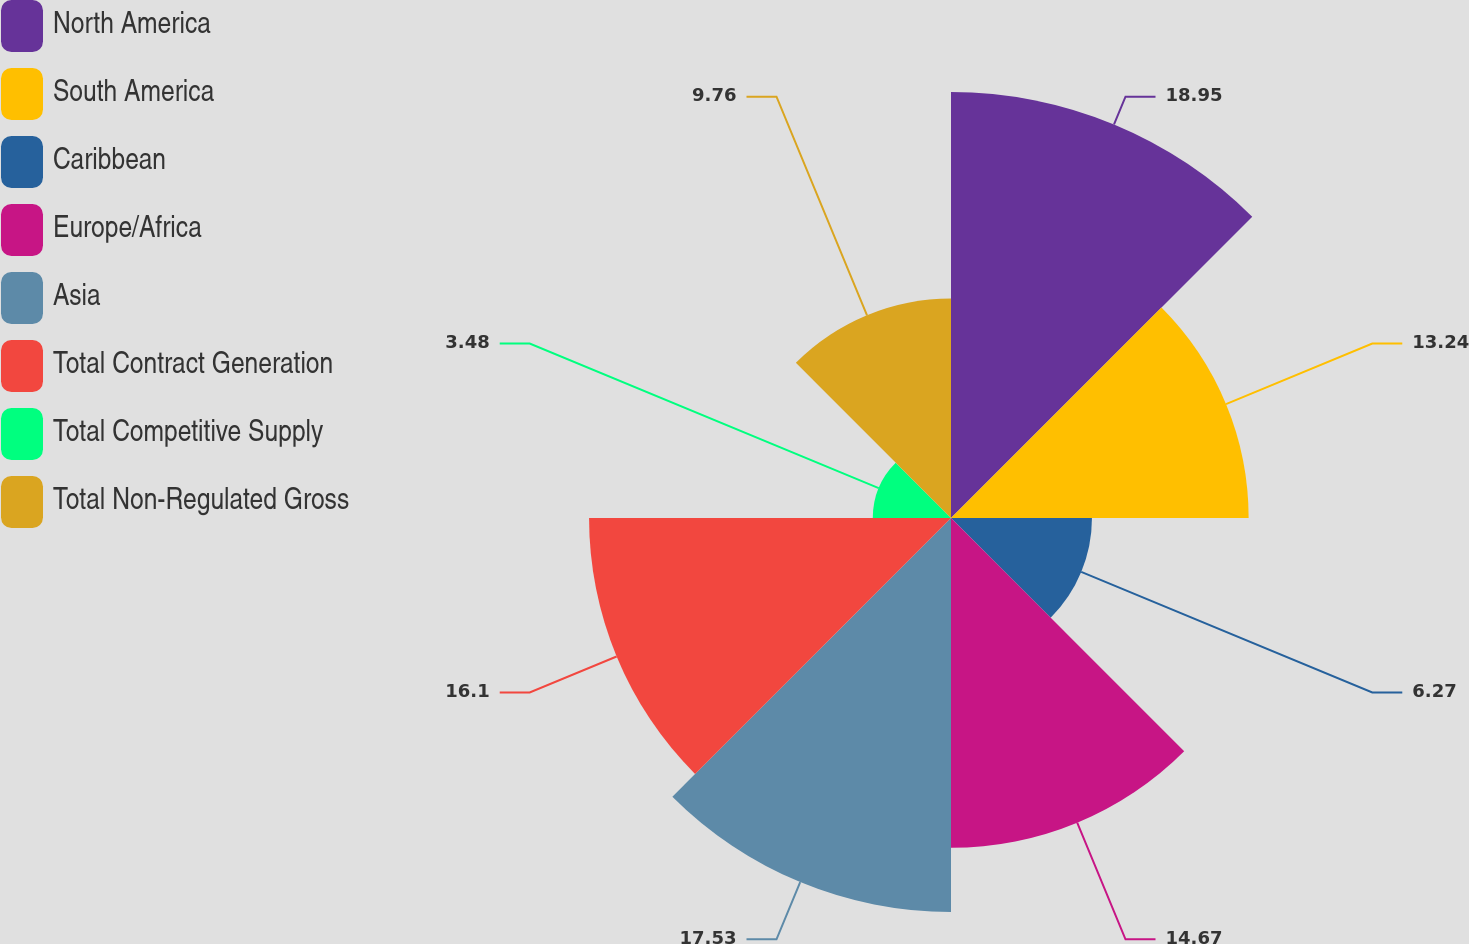Convert chart to OTSL. <chart><loc_0><loc_0><loc_500><loc_500><pie_chart><fcel>North America<fcel>South America<fcel>Caribbean<fcel>Europe/Africa<fcel>Asia<fcel>Total Contract Generation<fcel>Total Competitive Supply<fcel>Total Non-Regulated Gross<nl><fcel>18.95%<fcel>13.24%<fcel>6.27%<fcel>14.67%<fcel>17.53%<fcel>16.1%<fcel>3.48%<fcel>9.76%<nl></chart> 